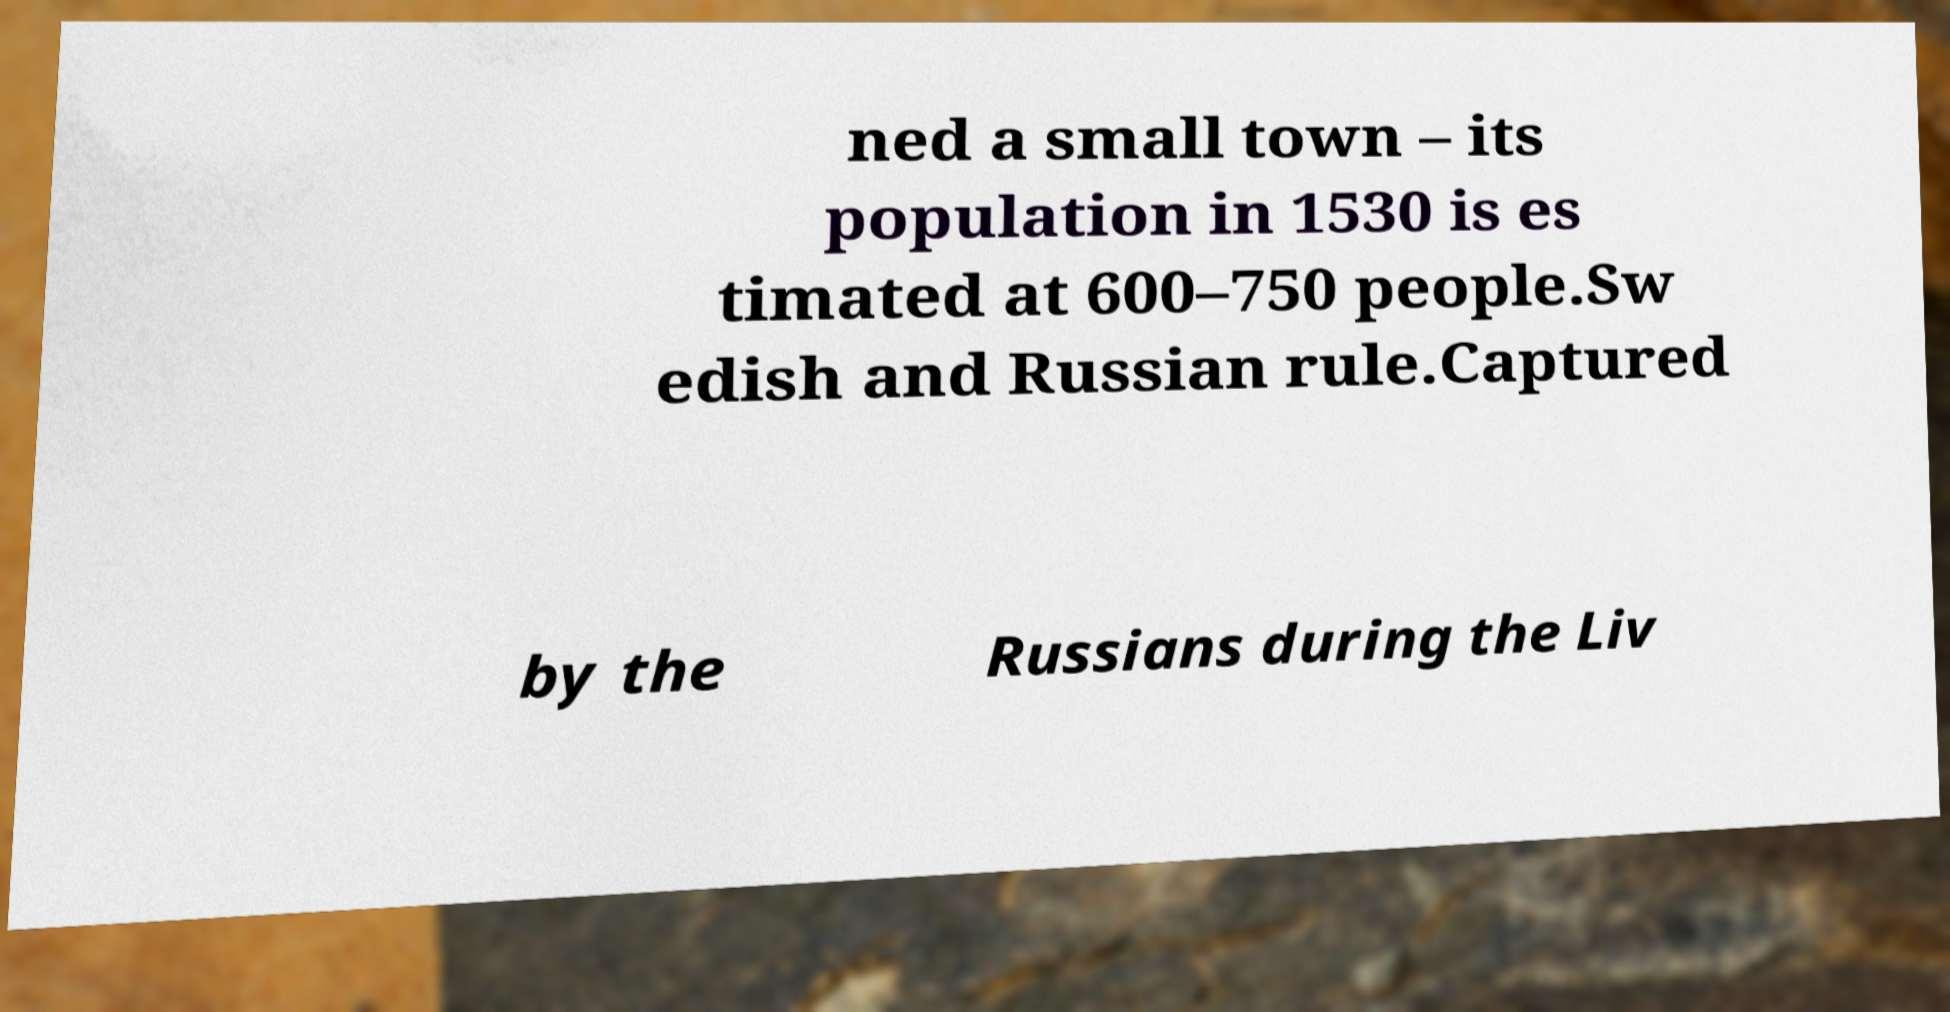For documentation purposes, I need the text within this image transcribed. Could you provide that? ned a small town – its population in 1530 is es timated at 600–750 people.Sw edish and Russian rule.Captured by the Russians during the Liv 